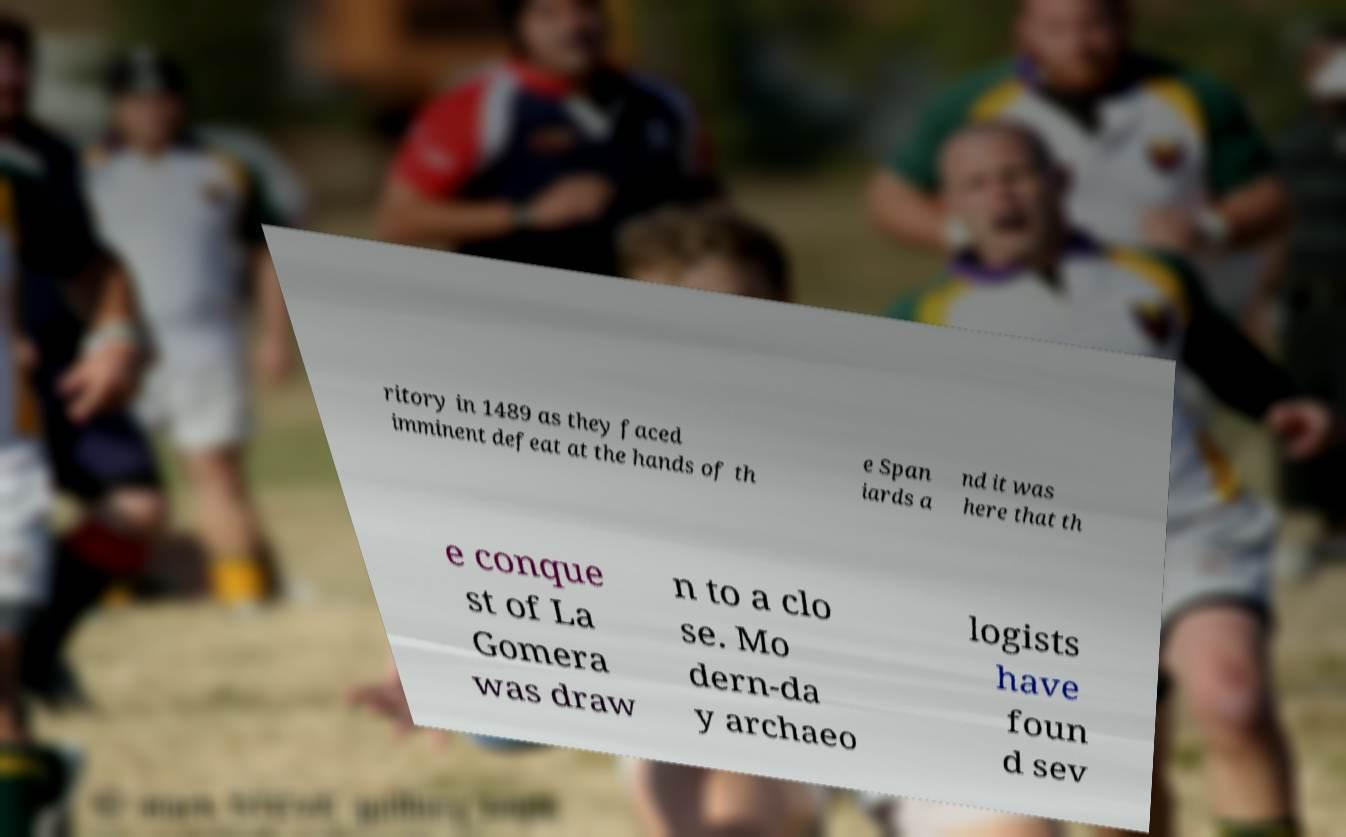There's text embedded in this image that I need extracted. Can you transcribe it verbatim? ritory in 1489 as they faced imminent defeat at the hands of th e Span iards a nd it was here that th e conque st of La Gomera was draw n to a clo se. Mo dern-da y archaeo logists have foun d sev 